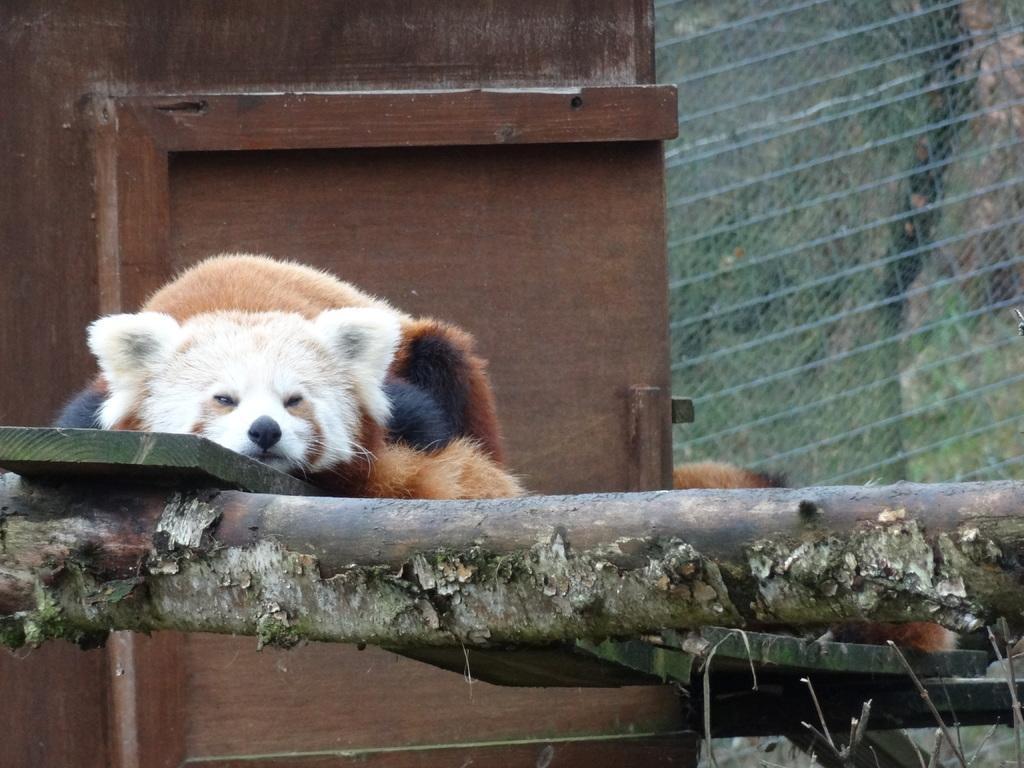How would you summarize this image in a sentence or two? In the image in the center, we can see one one wood. On the wood, we can see one bear, which is in brown, white and black color. In the background there is a wooden wall, one more bear, fence and the grass. 